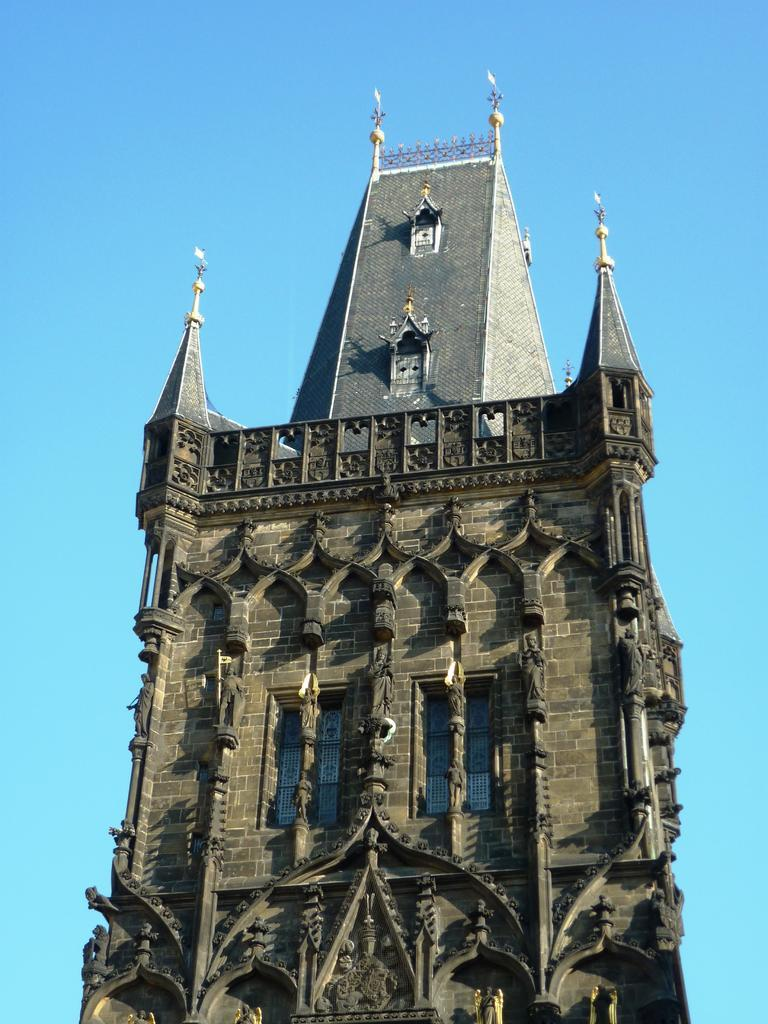What type of structure is present in the image? There is a building in the image. What part of the natural environment is visible in the image? The sky is visible in the image. How many chickens can be seen in the image? There are no chickens present in the image. Is there a ghost visible in the image? There is no ghost present in the image. 